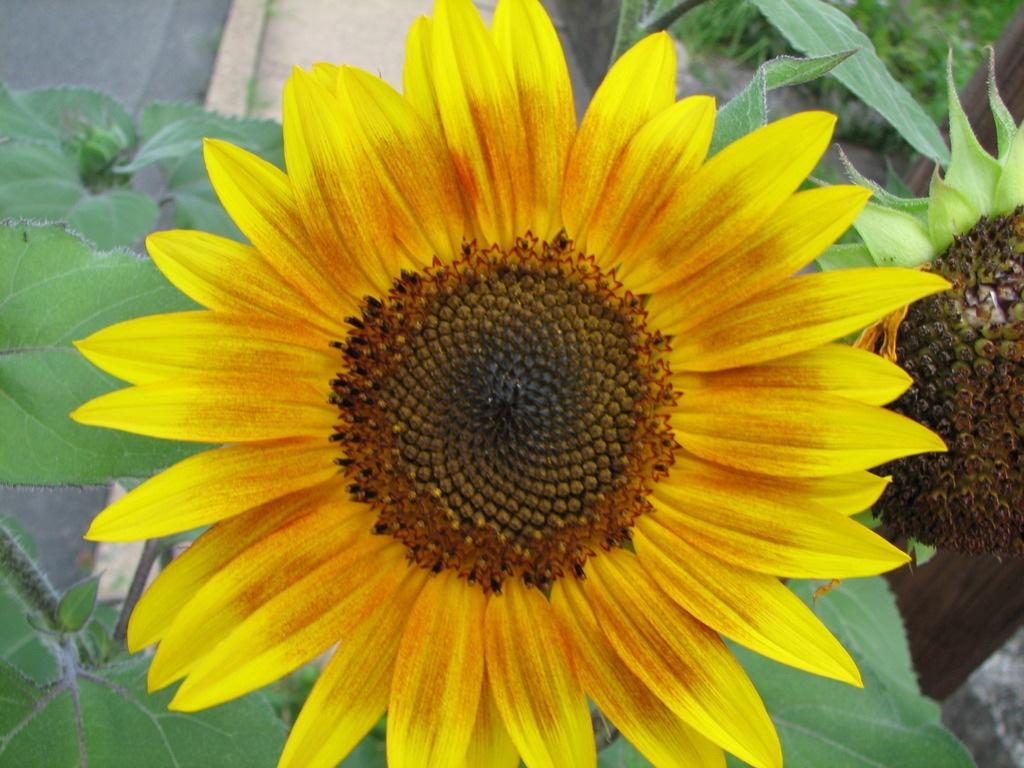What type of plant is featured in the image? There is a sunflower on a plant in the image. What can be seen in the background of the image? There is a road visible in the background of the image. What type of potato is being used to guide the sunflower in the image? There is no potato or guiding activity present in the image; it simply features a sunflower on a plant and a road in the background. 